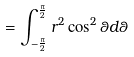<formula> <loc_0><loc_0><loc_500><loc_500>= \int _ { - \frac { \pi } { 2 } } ^ { \frac { \pi } { 2 } } r ^ { 2 } \cos ^ { 2 } \theta d \theta</formula> 